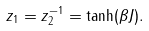Convert formula to latex. <formula><loc_0><loc_0><loc_500><loc_500>z _ { 1 } = z _ { 2 } ^ { - 1 } = \tanh ( \beta J ) .</formula> 